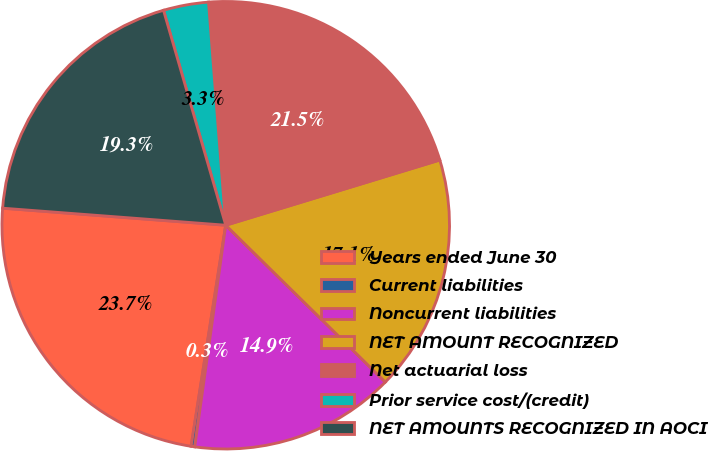Convert chart. <chart><loc_0><loc_0><loc_500><loc_500><pie_chart><fcel>Years ended June 30<fcel>Current liabilities<fcel>Noncurrent liabilities<fcel>NET AMOUNT RECOGNIZED<fcel>Net actuarial loss<fcel>Prior service cost/(credit)<fcel>NET AMOUNTS RECOGNIZED IN AOCI<nl><fcel>23.74%<fcel>0.26%<fcel>14.85%<fcel>17.07%<fcel>21.52%<fcel>3.26%<fcel>19.3%<nl></chart> 